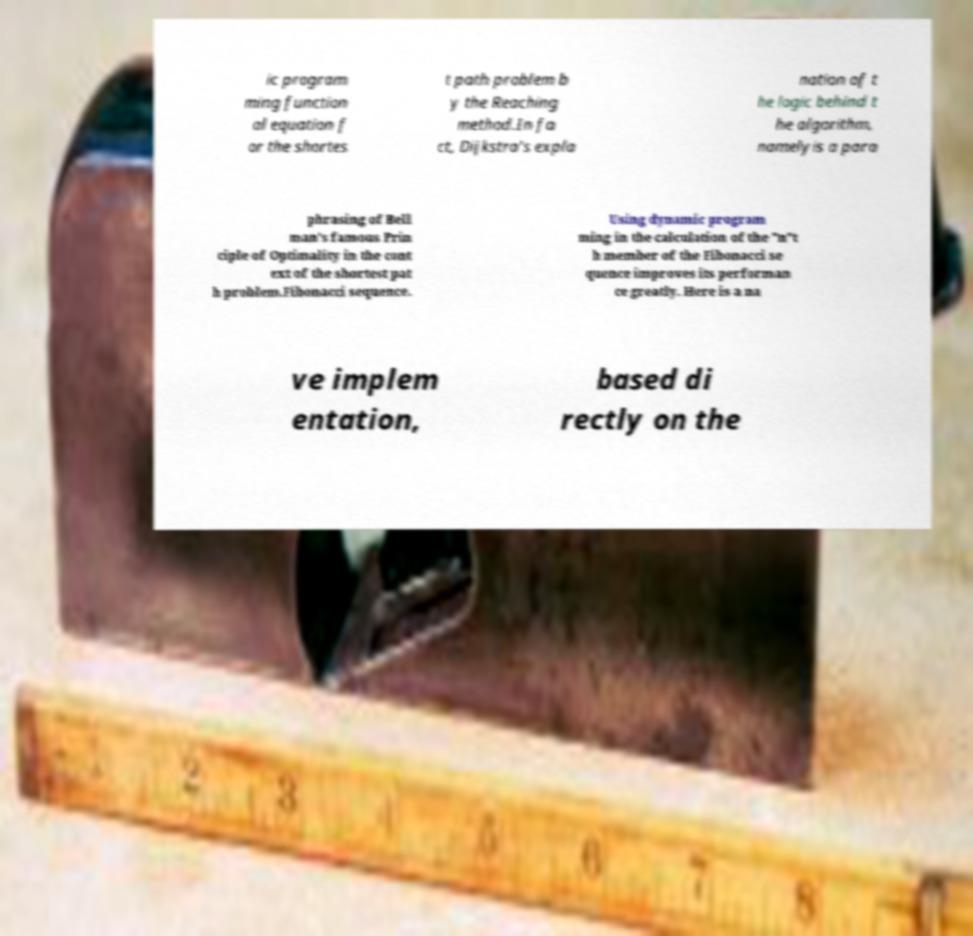What messages or text are displayed in this image? I need them in a readable, typed format. ic program ming function al equation f or the shortes t path problem b y the Reaching method.In fa ct, Dijkstra's expla nation of t he logic behind t he algorithm, namelyis a para phrasing of Bell man's famous Prin ciple of Optimality in the cont ext of the shortest pat h problem.Fibonacci sequence. Using dynamic program ming in the calculation of the "n"t h member of the Fibonacci se quence improves its performan ce greatly. Here is a na ve implem entation, based di rectly on the 